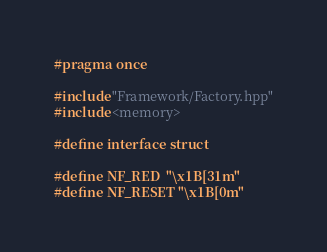Convert code to text. <code><loc_0><loc_0><loc_500><loc_500><_C_>#pragma once

#include "Framework/Factory.hpp"
#include <memory>

#define interface struct

#define NF_RED  "\x1B[31m"
#define NF_RESET "\x1B[0m"
</code> 